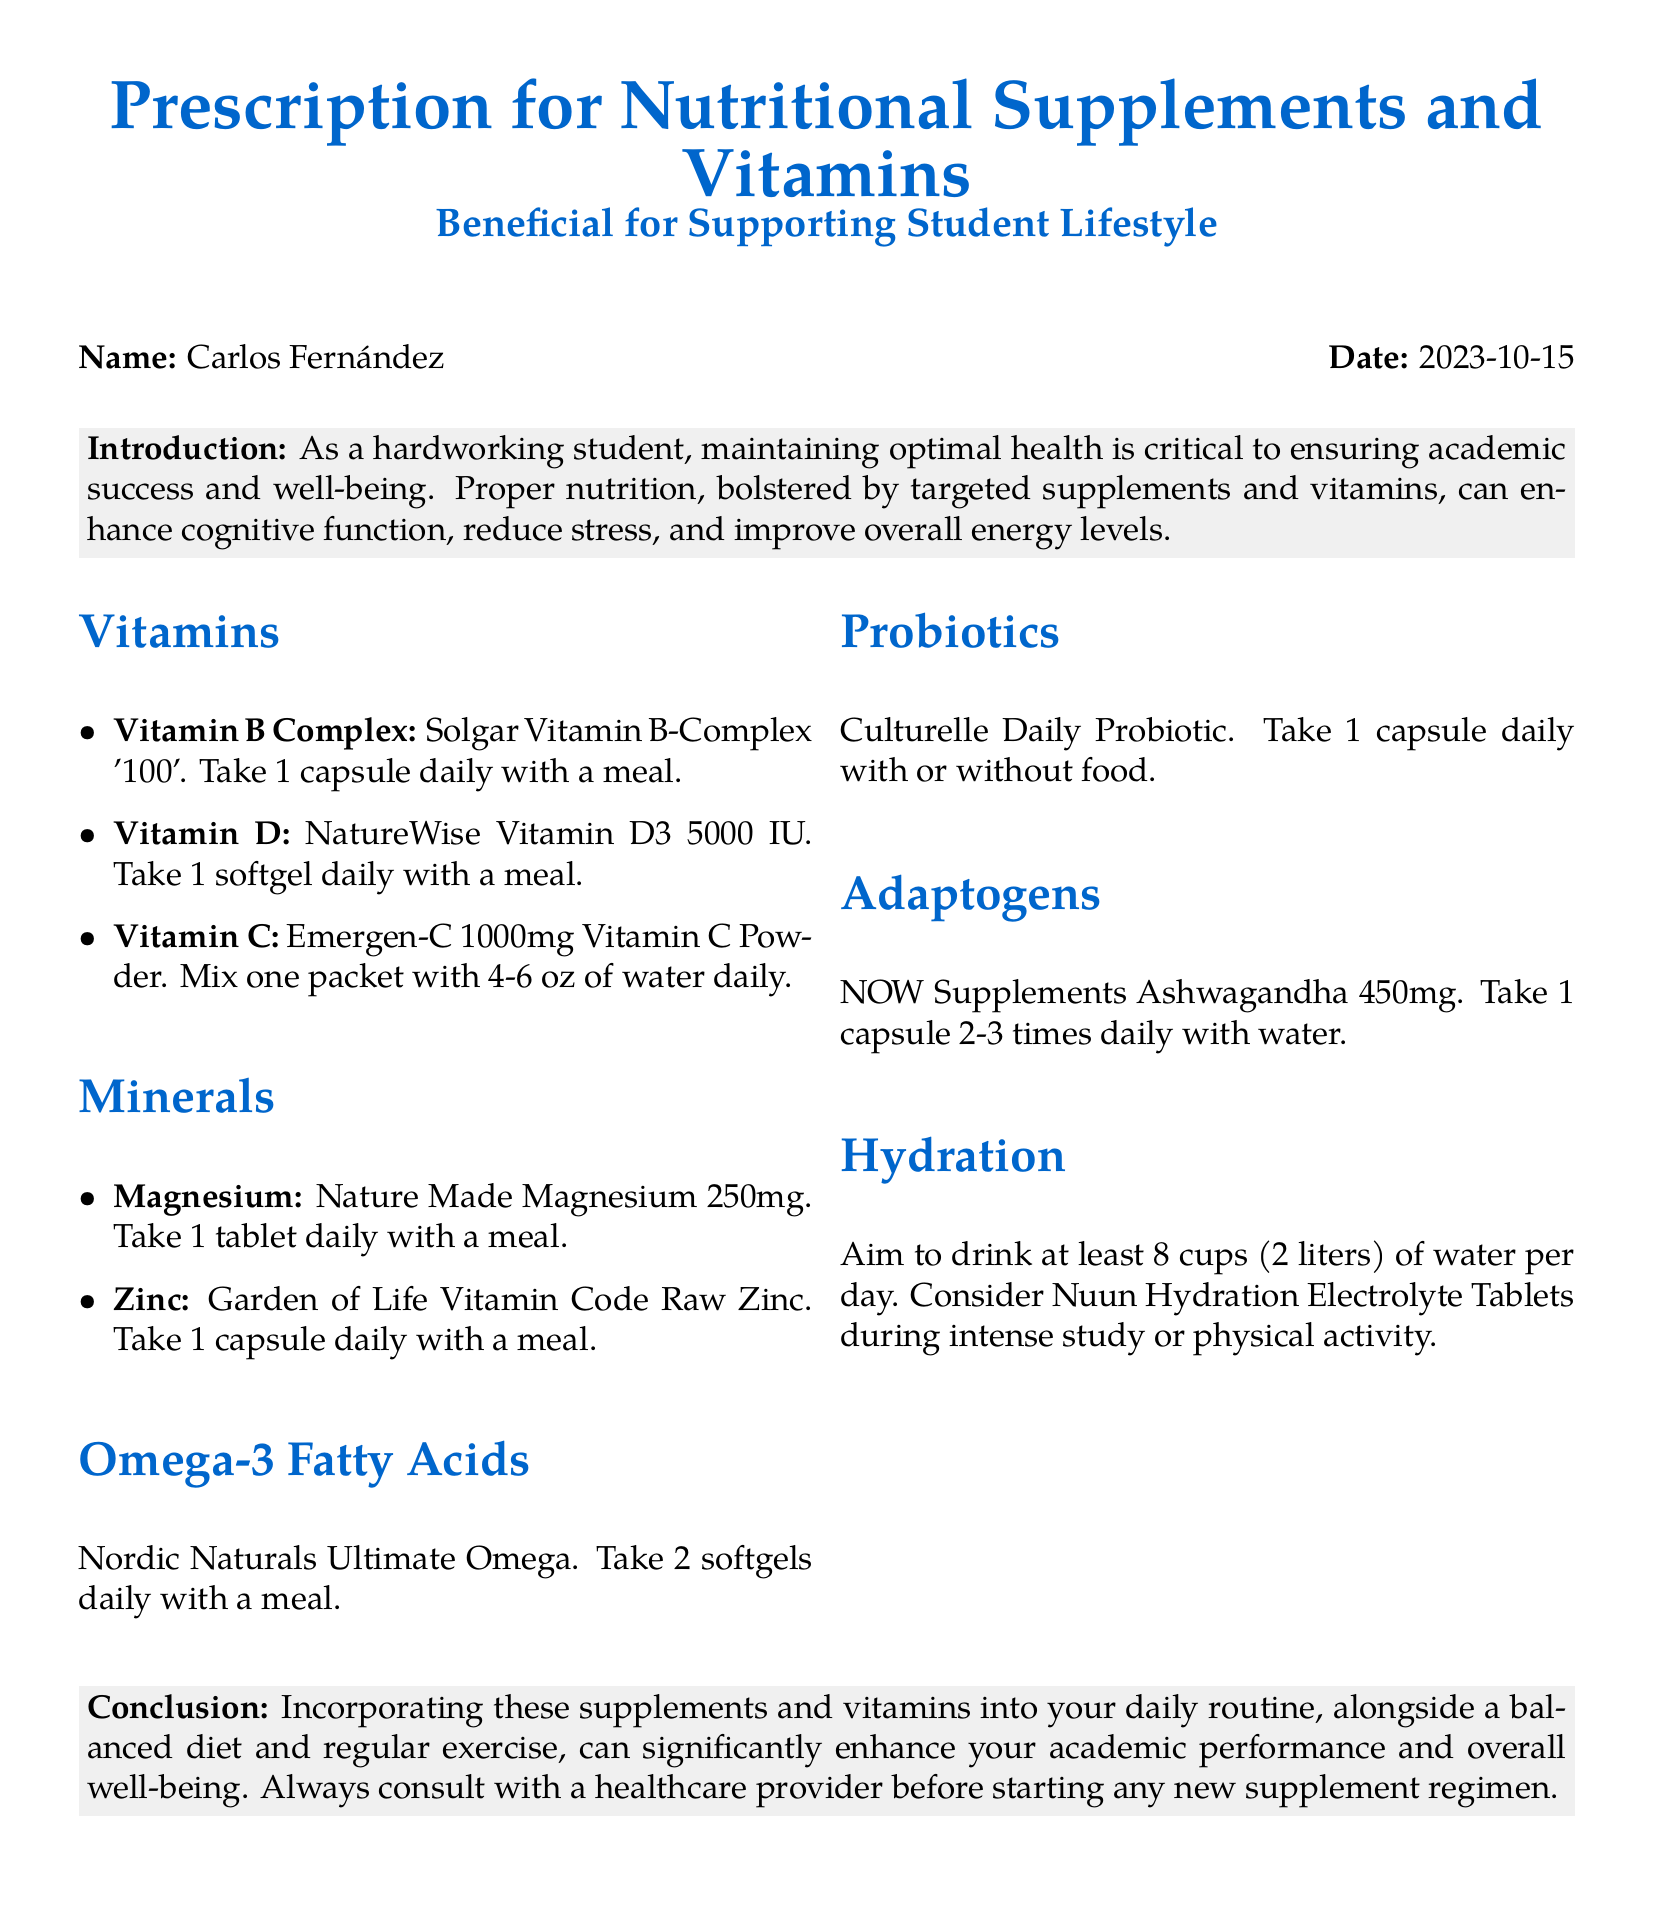What is the name of the person in the prescription? The name listed in the prescription is Carlos Fernández.
Answer: Carlos Fernández What is the date of the prescription? The date of the prescription is provided at the top of the document.
Answer: 2023-10-15 How many softgels of Omega-3 Fatty Acids should be taken daily? The dosage for Omega-3 Fatty Acids is specified in the document.
Answer: 2 softgels What is the recommended daily intake of water? The document states a specific goal for daily water consumption.
Answer: 8 cups (2 liters) Which vitamin has a dosage of 5000 IU? The document specifies the dosage of a particular vitamin.
Answer: Vitamin D What is the purpose of incorporating supplements according to the conclusion? The conclusion summarizes the benefits of the supplements mentioned in the document.
Answer: Enhance academic performance and overall well-being How often should Ashwagandha be taken? The document mentions the frequency for taking Ashwagandha.
Answer: 2-3 times daily What should be mixed with water for Vitamin C? The document specifies the form of Vitamin C to be consumed.
Answer: One packet of Emergen-C Which probiotic is recommended? The document lists a specific probiotic for daily use.
Answer: Culturelle Daily Probiotic 